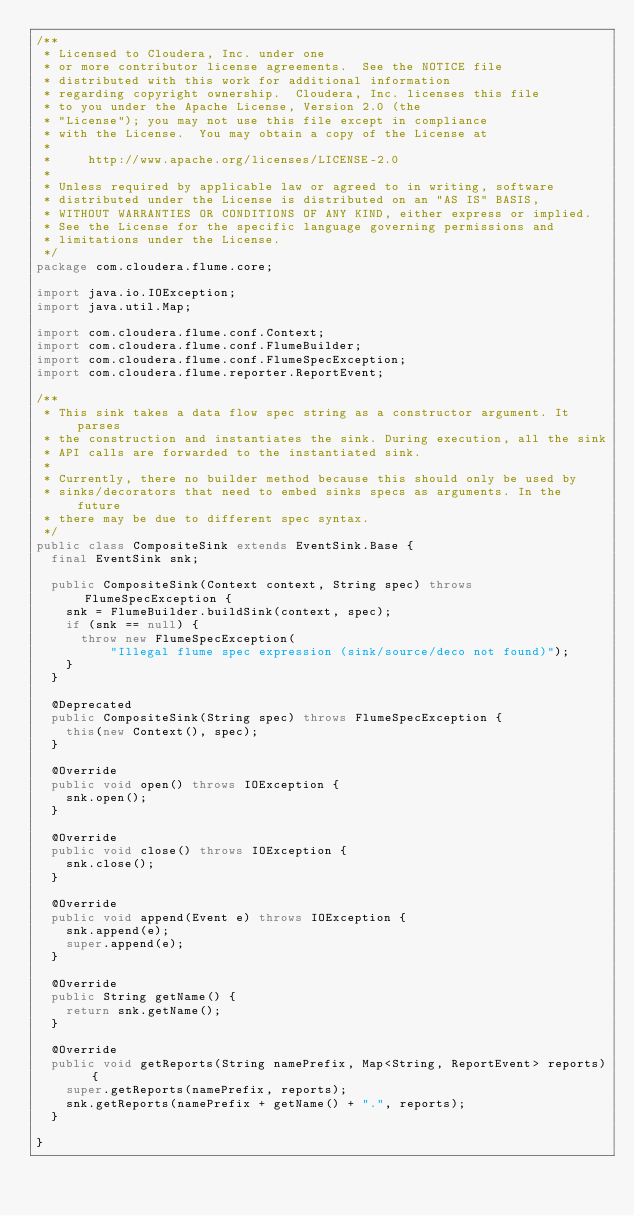<code> <loc_0><loc_0><loc_500><loc_500><_Java_>/**
 * Licensed to Cloudera, Inc. under one
 * or more contributor license agreements.  See the NOTICE file
 * distributed with this work for additional information
 * regarding copyright ownership.  Cloudera, Inc. licenses this file
 * to you under the Apache License, Version 2.0 (the
 * "License"); you may not use this file except in compliance
 * with the License.  You may obtain a copy of the License at
 *
 *     http://www.apache.org/licenses/LICENSE-2.0
 *
 * Unless required by applicable law or agreed to in writing, software
 * distributed under the License is distributed on an "AS IS" BASIS,
 * WITHOUT WARRANTIES OR CONDITIONS OF ANY KIND, either express or implied.
 * See the License for the specific language governing permissions and
 * limitations under the License.
 */
package com.cloudera.flume.core;

import java.io.IOException;
import java.util.Map;

import com.cloudera.flume.conf.Context;
import com.cloudera.flume.conf.FlumeBuilder;
import com.cloudera.flume.conf.FlumeSpecException;
import com.cloudera.flume.reporter.ReportEvent;

/**
 * This sink takes a data flow spec string as a constructor argument. It parses
 * the construction and instantiates the sink. During execution, all the sink
 * API calls are forwarded to the instantiated sink.
 * 
 * Currently, there no builder method because this should only be used by
 * sinks/decorators that need to embed sinks specs as arguments. In the future
 * there may be due to different spec syntax.
 */
public class CompositeSink extends EventSink.Base {
  final EventSink snk;

  public CompositeSink(Context context, String spec) throws FlumeSpecException {
    snk = FlumeBuilder.buildSink(context, spec);
    if (snk == null) {
      throw new FlumeSpecException(
          "Illegal flume spec expression (sink/source/deco not found)");
    }
  }

  @Deprecated
  public CompositeSink(String spec) throws FlumeSpecException {
    this(new Context(), spec);
  }

  @Override
  public void open() throws IOException {
    snk.open();
  }

  @Override
  public void close() throws IOException {
    snk.close();
  }

  @Override
  public void append(Event e) throws IOException {
    snk.append(e);
    super.append(e);
  }

  @Override
  public String getName() {
    return snk.getName();
  }

  @Override
  public void getReports(String namePrefix, Map<String, ReportEvent> reports) {
    super.getReports(namePrefix, reports);
    snk.getReports(namePrefix + getName() + ".", reports);
  }

}
</code> 